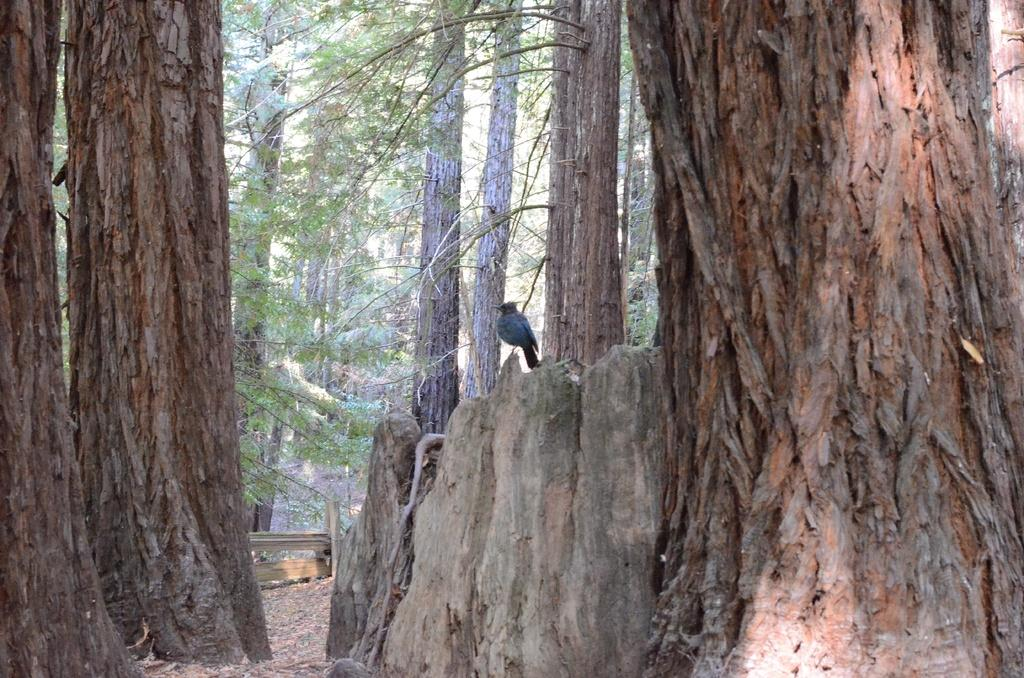What type of vegetation can be seen in the image? There are trees in the image. Is there any wildlife present in the image? Yes, there is a crow on the bark of a tree. What type of barrier can be seen in the image? There is a wooden fence in the image. Can you see any snails crawling on the sidewalk in the image? There is no sidewalk present in the image, and therefore no snails can be seen crawling on it. 